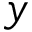Convert formula to latex. <formula><loc_0><loc_0><loc_500><loc_500>y</formula> 